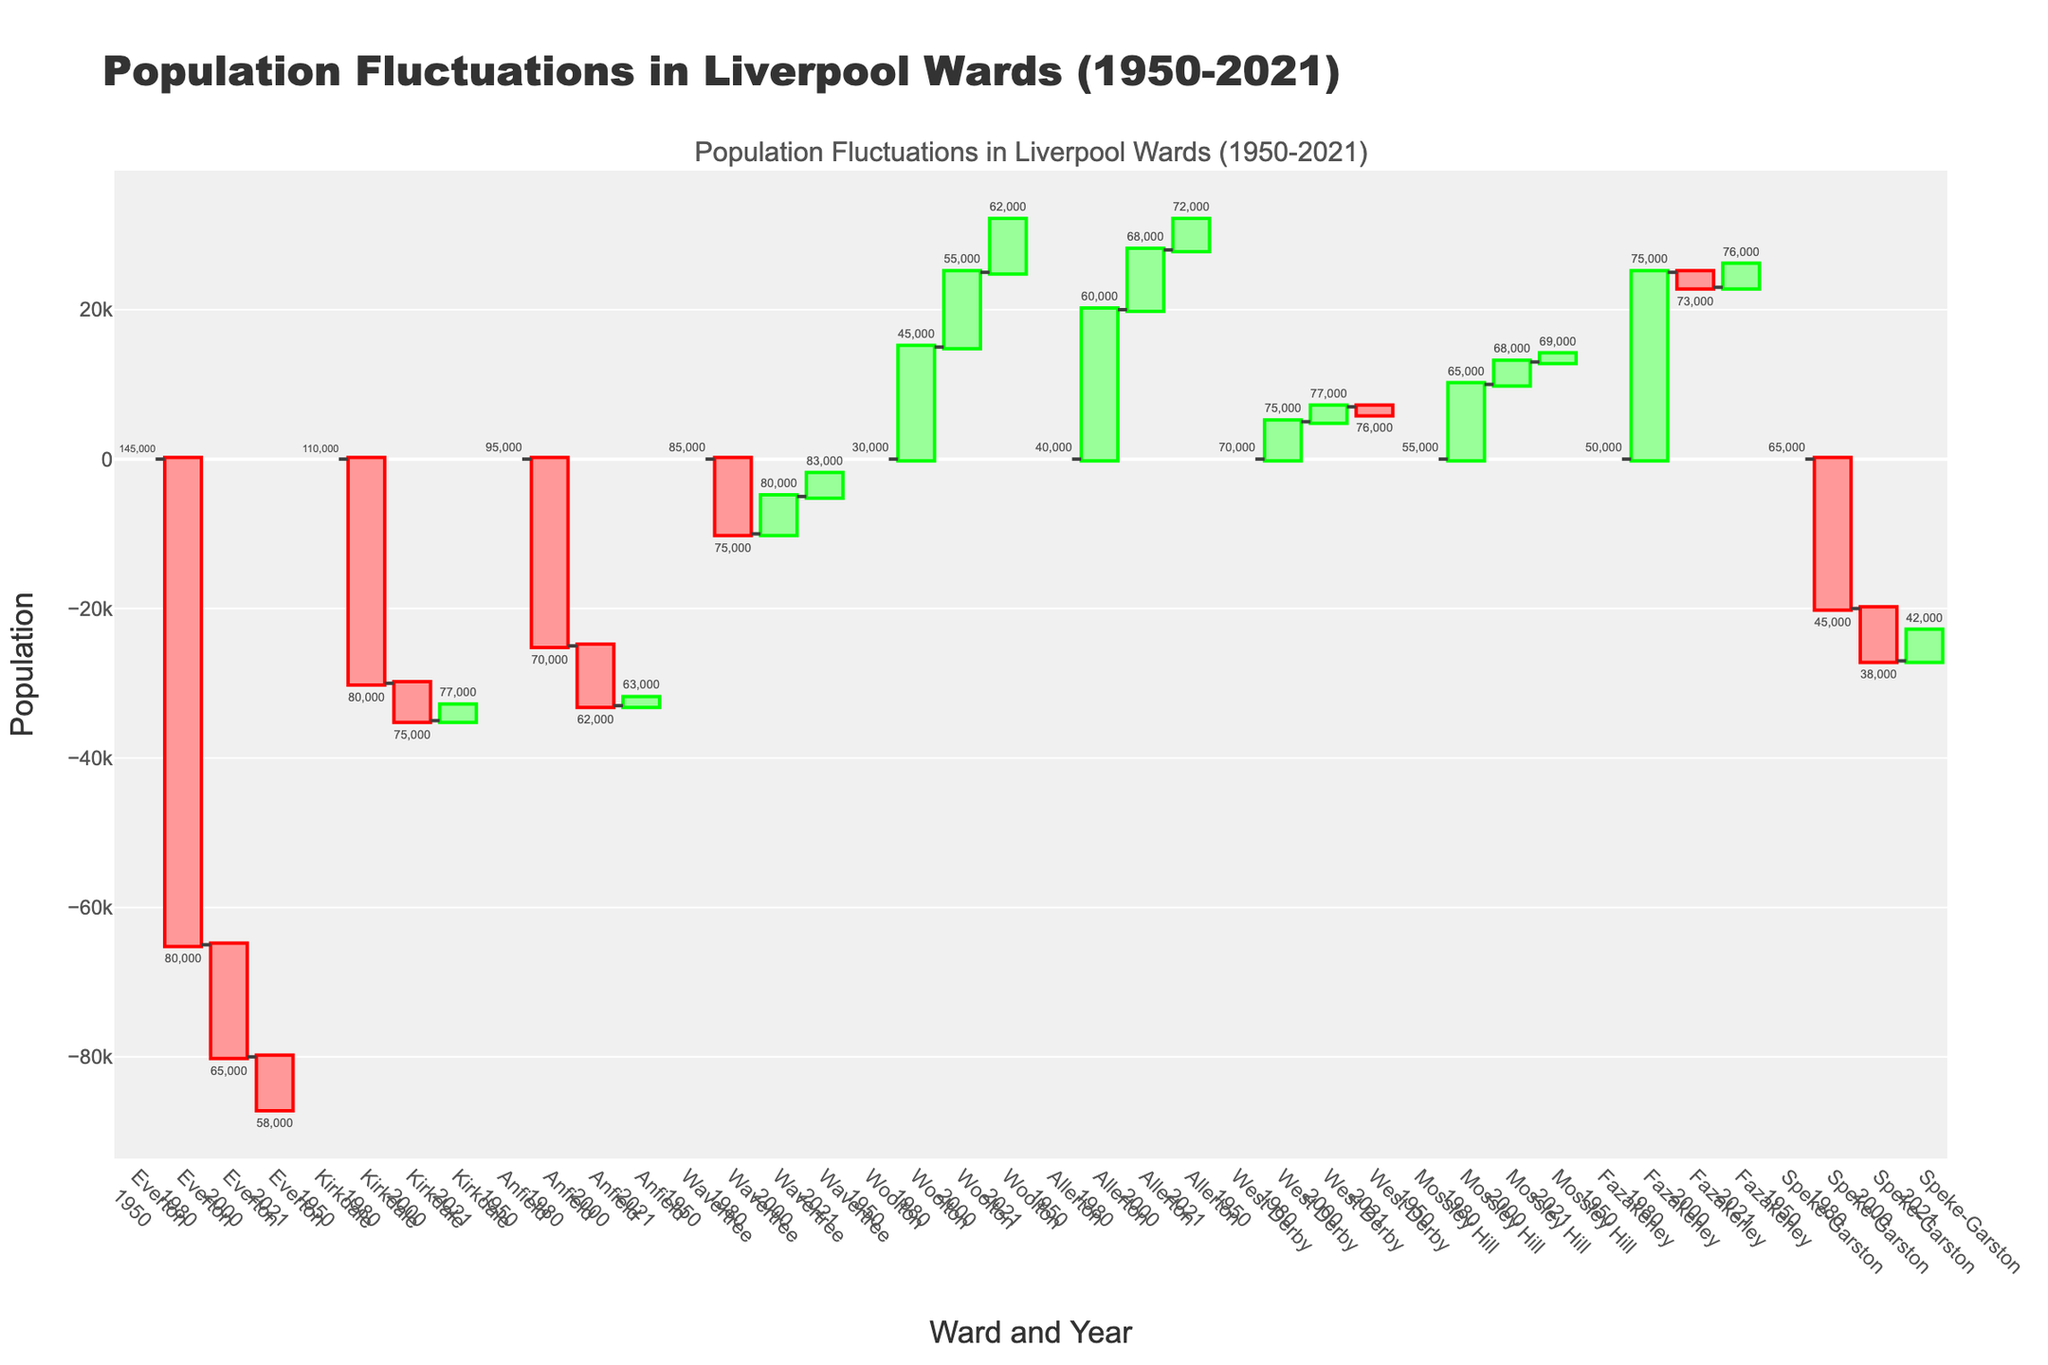What is the title of the chart? The title of the chart is usually positioned at the top and is meant to provide a quick understanding of what the chart represents.
Answer: Population Fluctuations in Liverpool Wards (1950-2021) Which ward had the highest population in 1950? The chart shows the initial population values for each ward in 1950. The highest value will be the tallest bar corresponding to this year.
Answer: Everton How did the population of Woolton change from 1950 to 2021? Look at the starting value in 1950 and the final value in 2021 for Woolton, then calculate the difference. Woolton had a population increase in all periods shown in the chart.
Answer: Increased by 32,000 Which ward experienced the largest decrease in population between 1950 and 1980? By examining the change values for each ward between 1950 and 1980, find the largest negative number.
Answer: Everton In 2021, which ward had a larger population, Anfield or Kirkdale? Compare the final values in 2021 for both Anfield and Kirkdale.
Answer: Kirkdale What was the total population change for Everton from 1950 to 2000? Add up all the population changes for Everton from 1950 to 2000.
Answer: Decreased by 80,000 How does the population trend of Allerton from 1950 to 2021 differ from that of Speke-Garston? Compare the population changes for both Allerton and Speke-Garston. Note the trends: consistent increases for Allerton vs. a decrease in Speke-Garston up until 1980, then smaller changes afterward.
Answer: Allerton increased consistently, while Speke-Garston largely decreased Which ward had the smallest population in 2000? Look for the shortest bar corresponding to the year 2000.
Answer: Speke-Garston Did any ward experience a population increase in both periods 1980-2000 and 2000-2021? Identify wards that show positive changes in both given periods by examining the chart for these specific years.
Answer: Woolton, Allerton, Wavertree, Mossley Hill, Fazakerley How did the population of Fazakerley change from 1980 to 2021? Look at the change values between 1980 and 2000, and between 2000 and 2021 for Fazakerley. Sum these changes to find the total change over the period.
Answer: Increased by 1,000 